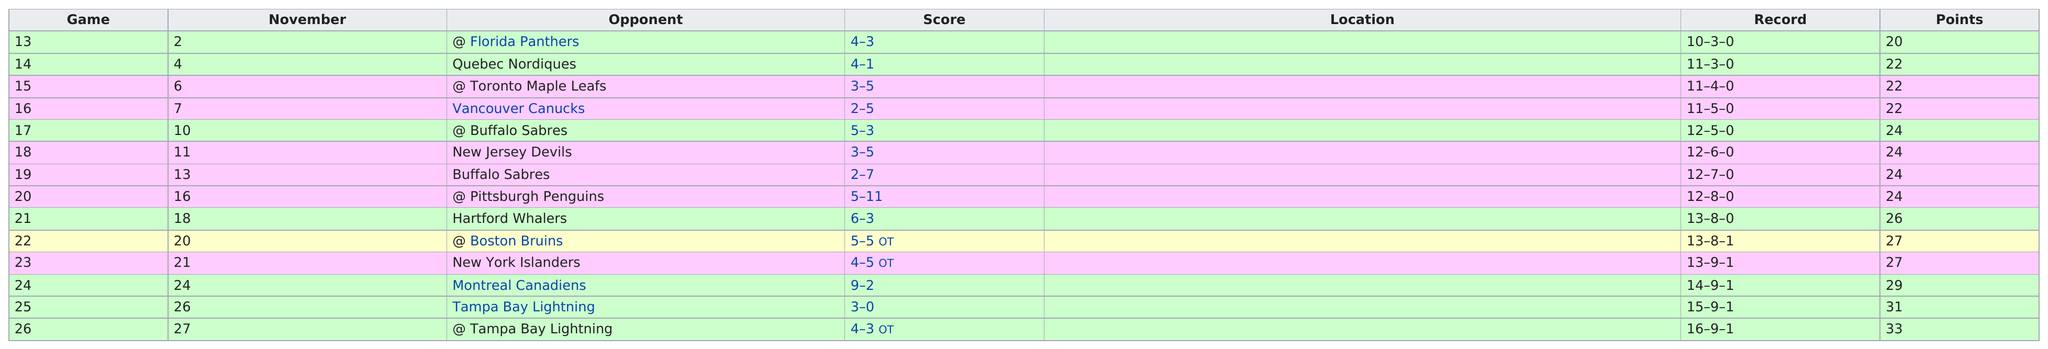Indicate a few pertinent items in this graphic. The Philadelphia Flyers missed the playoffs for the 5th consecutive season from 1988-1989 to 1992-1993. Mark Recchi was the Flyers player who had the most assists during the 1993-1994 season. The New York Islanders were the team with the next closest amount of wins to the Washington Capitals, who won the Stanley Cup this season. I have determined that Dave Brown had a total of 137 penalty minutes during the 1993-1994 season with the Philadelphia Flyers The New Jersey Devils were not in last place according to the chart, as clearly demonstrated by the data. 